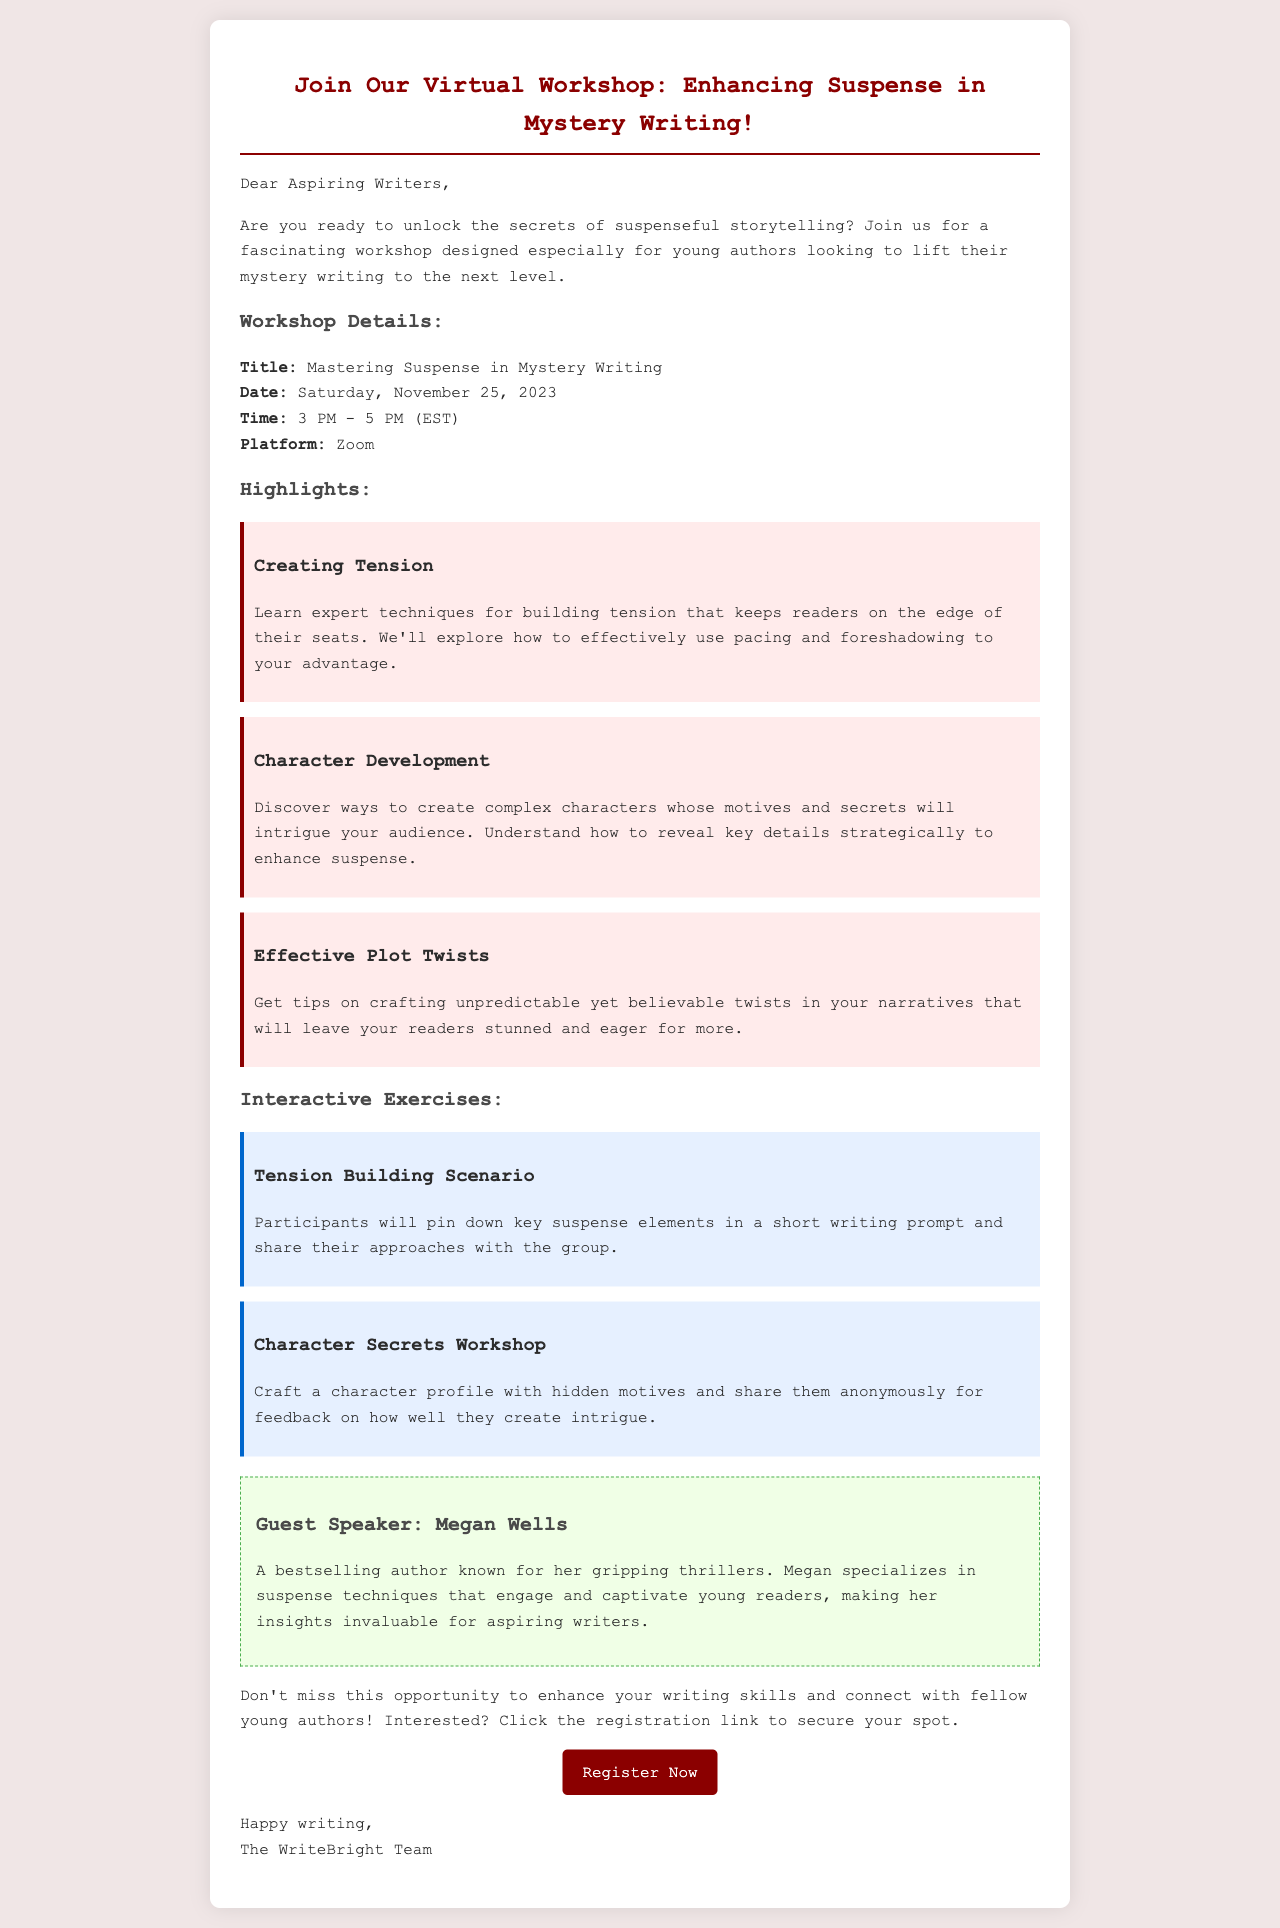What is the title of the workshop? The title of the workshop is explicitly stated in the document as "Mastering Suspense in Mystery Writing."
Answer: Mastering Suspense in Mystery Writing What date is the workshop scheduled for? The workshop date is clearly mentioned in the details section as "Saturday, November 25, 2023."
Answer: Saturday, November 25, 2023 Who is the guest speaker? The document identifies the guest speaker as "Megan Wells."
Answer: Megan Wells What time does the workshop start? The starting time for the workshop is provided in the details section as "3 PM."
Answer: 3 PM What is one of the key highlights of the workshop? The document lists multiple highlights; one is "Creating Tension."
Answer: Creating Tension What platform will be used for the workshop? The platform for the workshop is detailed in the document as "Zoom."
Answer: Zoom What is one type of interactive exercise mentioned? The document describes "Tension Building Scenario" as one of the interactive exercises.
Answer: Tension Building Scenario How long is the workshop scheduled to last? The total duration of the workshop is specified as "2 hours."
Answer: 2 hours What is the registration link to secure a spot? The registration link is provided in the text as "https://www.writebright.com/register."
Answer: https://www.writebright.com/register 